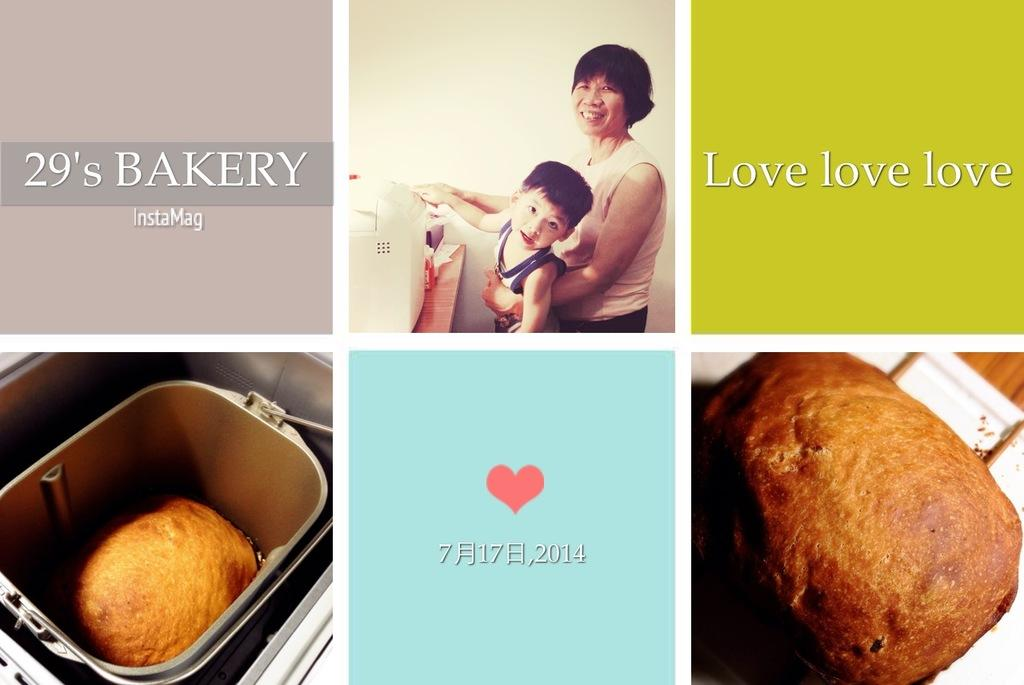<image>
Share a concise interpretation of the image provided. A place called the 29's Bakery wants to show love. 